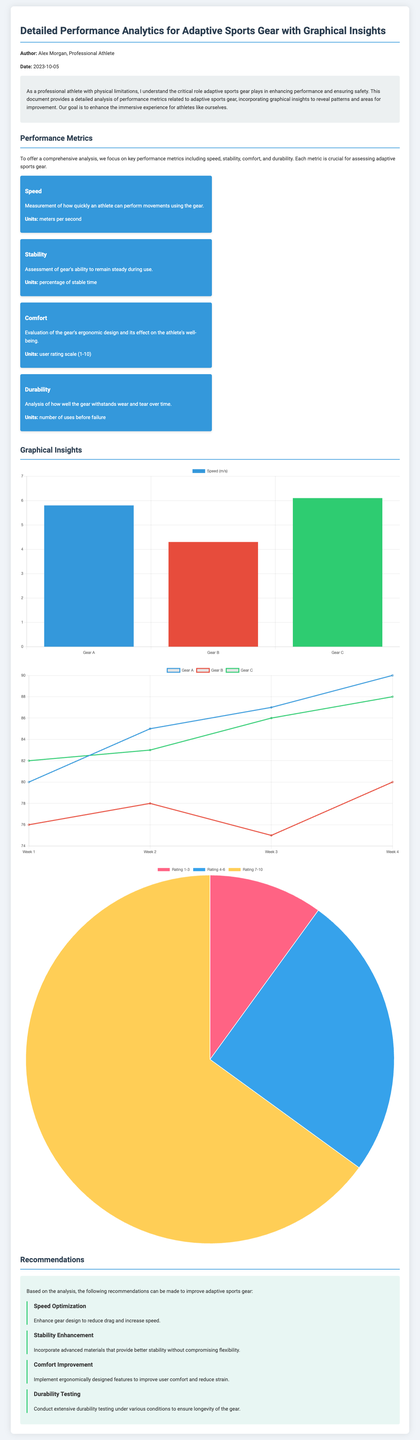what is the name of the author? The document states that the author is a professional athlete named Alex Morgan.
Answer: Alex Morgan what is the date of the document? The document specifies that it was created on October 5, 2023.
Answer: 2023-10-05 what metric is used to assess stability? The stability metric is assessed based on the percentage of stable time.
Answer: percentage of stable time what is the user rating scale for comfort? The comfort evaluation uses a user rating scale from 1 to 10.
Answer: 1-10 which gear has the highest speed according to the chart? The speed chart indicates that Gear C has the highest speed measurement at 6.1 m/s.
Answer: Gear C what is the improvement recommendation for speed? The recommendation states to enhance gear design to reduce drag and increase speed.
Answer: Enhance gear design to reduce drag and increase speed what is the durability metric based on? The durability metric is based on the number of uses before failure of the gear.
Answer: number of uses before failure which gear had the highest stability rating in Week 4? In Week 4, Gear A had the highest stability rating at 90%.
Answer: Gear A what type of chart represents User Comfort Rating? The User Comfort Rating is represented using a pie chart.
Answer: pie chart 